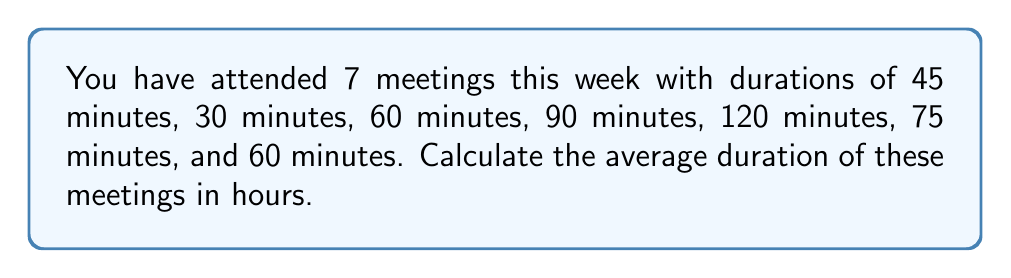Can you solve this math problem? To calculate the average duration of meetings, we need to follow these steps:

1. Sum up the total duration of all meetings:
   $45 + 30 + 60 + 90 + 120 + 75 + 60 = 480$ minutes

2. Count the total number of meetings:
   There are 7 meetings in total.

3. Calculate the average duration in minutes:
   Average duration = Total duration / Number of meetings
   $\frac{480}{7} = 68.57$ minutes

4. Convert the average duration from minutes to hours:
   $68.57 \text{ minutes} \times \frac{1 \text{ hour}}{60 \text{ minutes}} = 1.14$ hours

Therefore, the average duration of meetings over the week is 1.14 hours.
Answer: 1.14 hours 